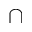<formula> <loc_0><loc_0><loc_500><loc_500>\cap</formula> 